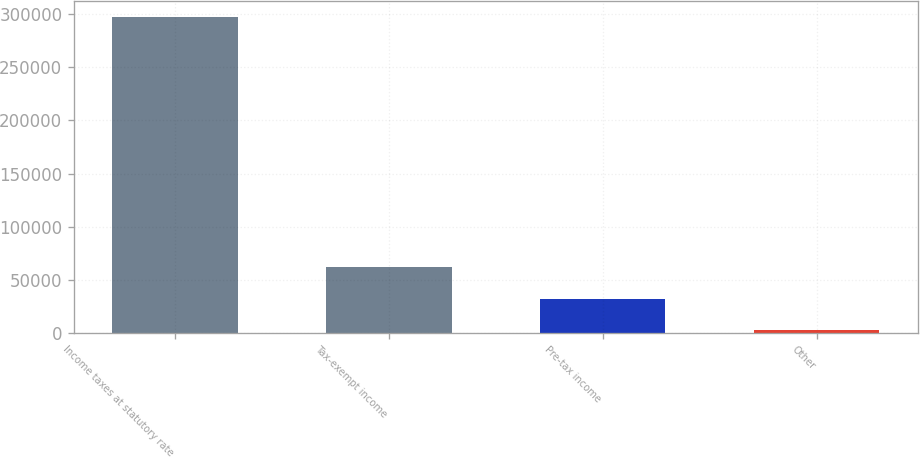Convert chart to OTSL. <chart><loc_0><loc_0><loc_500><loc_500><bar_chart><fcel>Income taxes at statutory rate<fcel>Tax-exempt income<fcel>Pre-tax income<fcel>Other<nl><fcel>297735<fcel>61682.2<fcel>32175.6<fcel>2669<nl></chart> 